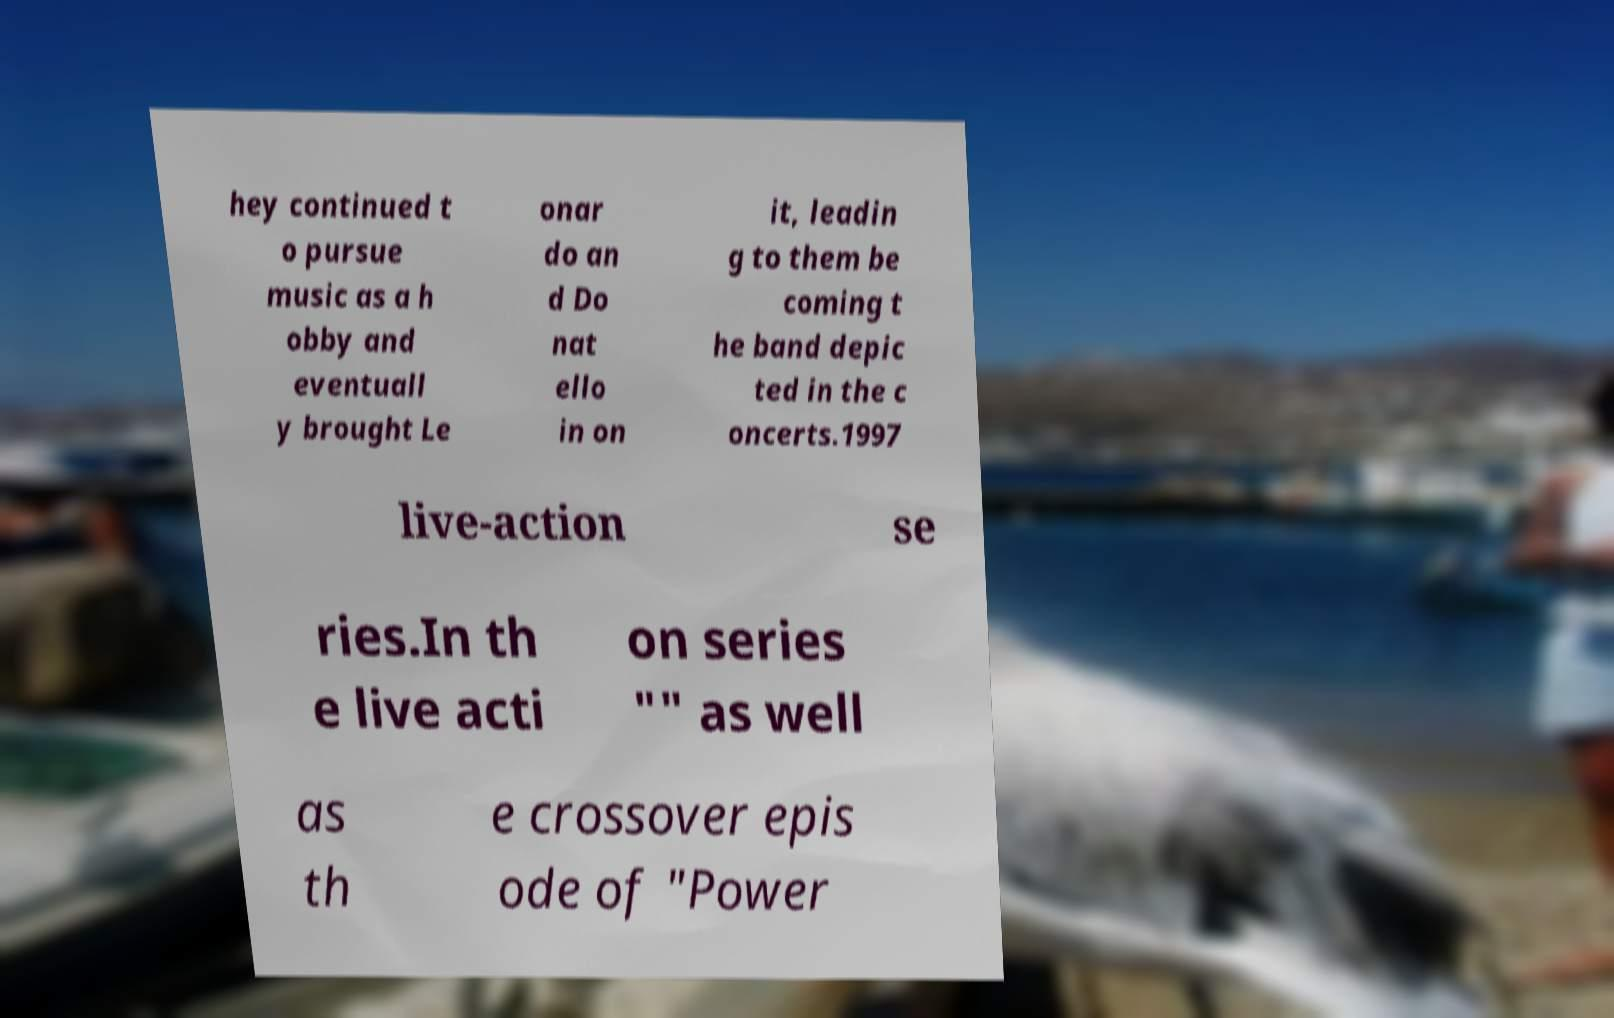What messages or text are displayed in this image? I need them in a readable, typed format. hey continued t o pursue music as a h obby and eventuall y brought Le onar do an d Do nat ello in on it, leadin g to them be coming t he band depic ted in the c oncerts.1997 live-action se ries.In th e live acti on series "" as well as th e crossover epis ode of "Power 